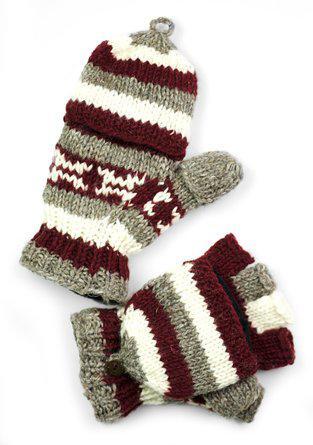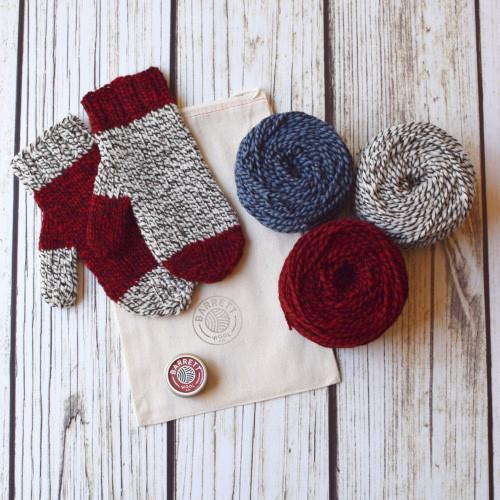The first image is the image on the left, the second image is the image on the right. For the images shown, is this caption "No image shows more than one pair of """"mittens"""" or any other wearable item, and at least one mitten pair has gray and dark red colors." true? Answer yes or no. Yes. The first image is the image on the left, the second image is the image on the right. Considering the images on both sides, is "One pair of knit gloves are being worn on someone's hands." valid? Answer yes or no. No. 